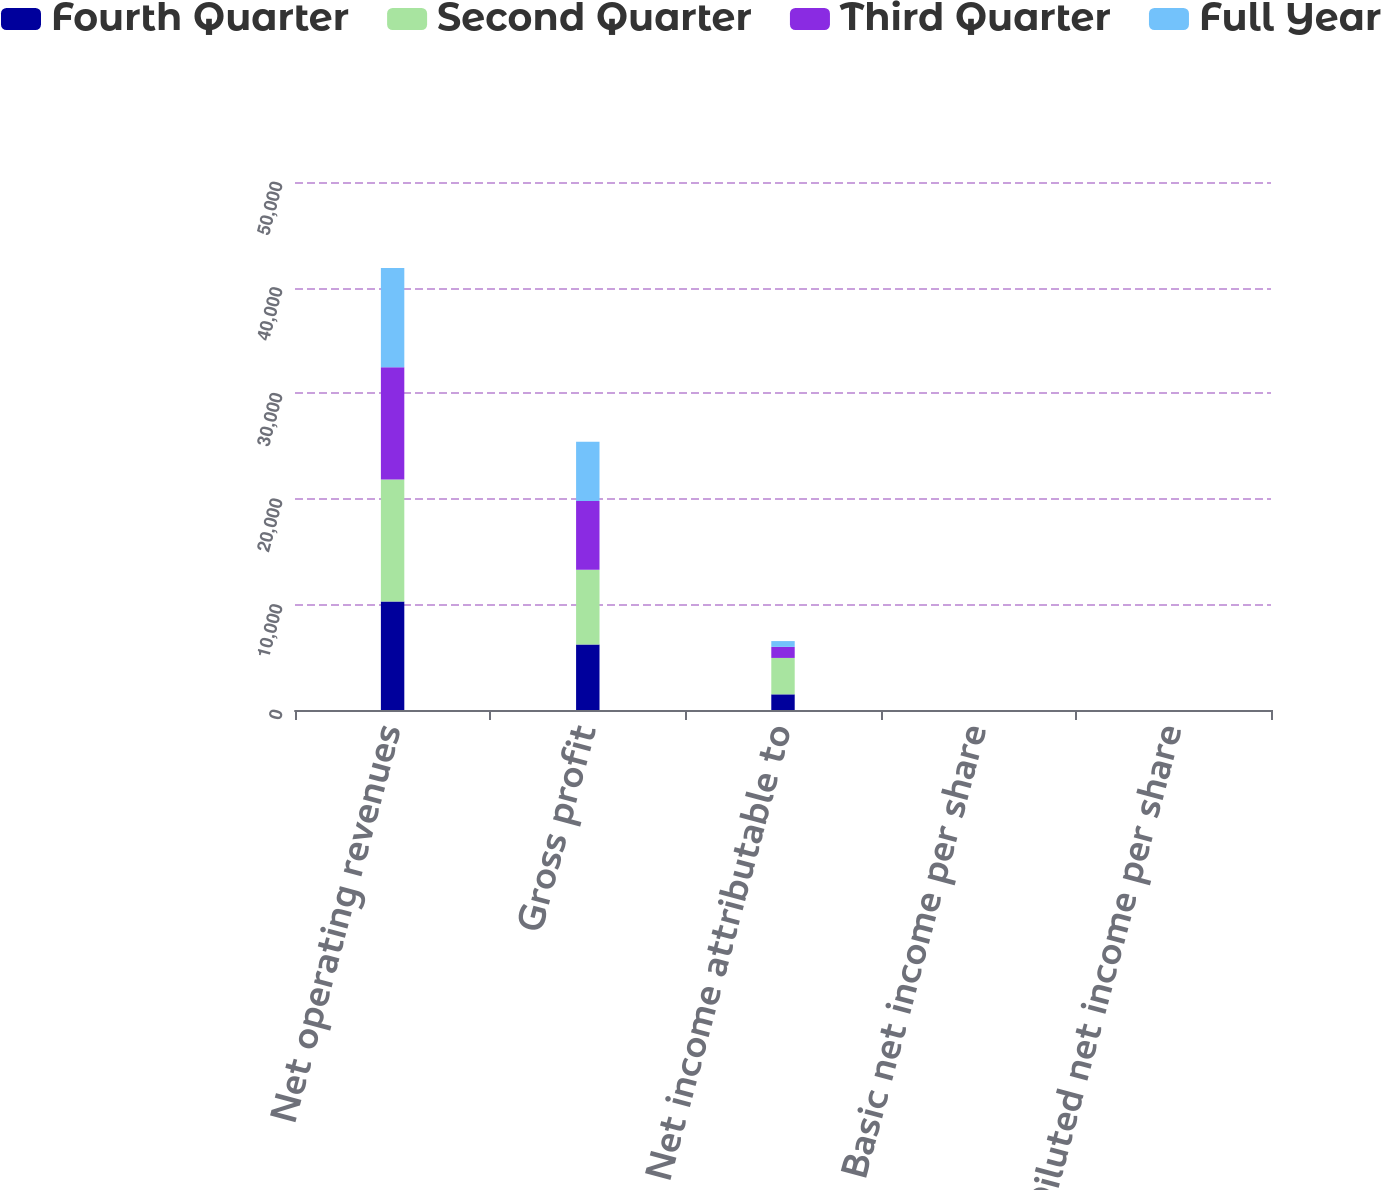Convert chart to OTSL. <chart><loc_0><loc_0><loc_500><loc_500><stacked_bar_chart><ecel><fcel>Net operating revenues<fcel>Gross profit<fcel>Net income attributable to<fcel>Basic net income per share<fcel>Diluted net income per share<nl><fcel>Fourth Quarter<fcel>10282<fcel>6213<fcel>1483<fcel>0.34<fcel>0.34<nl><fcel>Second Quarter<fcel>11539<fcel>7068<fcel>3448<fcel>0.8<fcel>0.79<nl><fcel>Third Quarter<fcel>10633<fcel>6502<fcel>1046<fcel>0.24<fcel>0.24<nl><fcel>Full Year<fcel>9409<fcel>5615<fcel>550<fcel>0.13<fcel>0.13<nl></chart> 